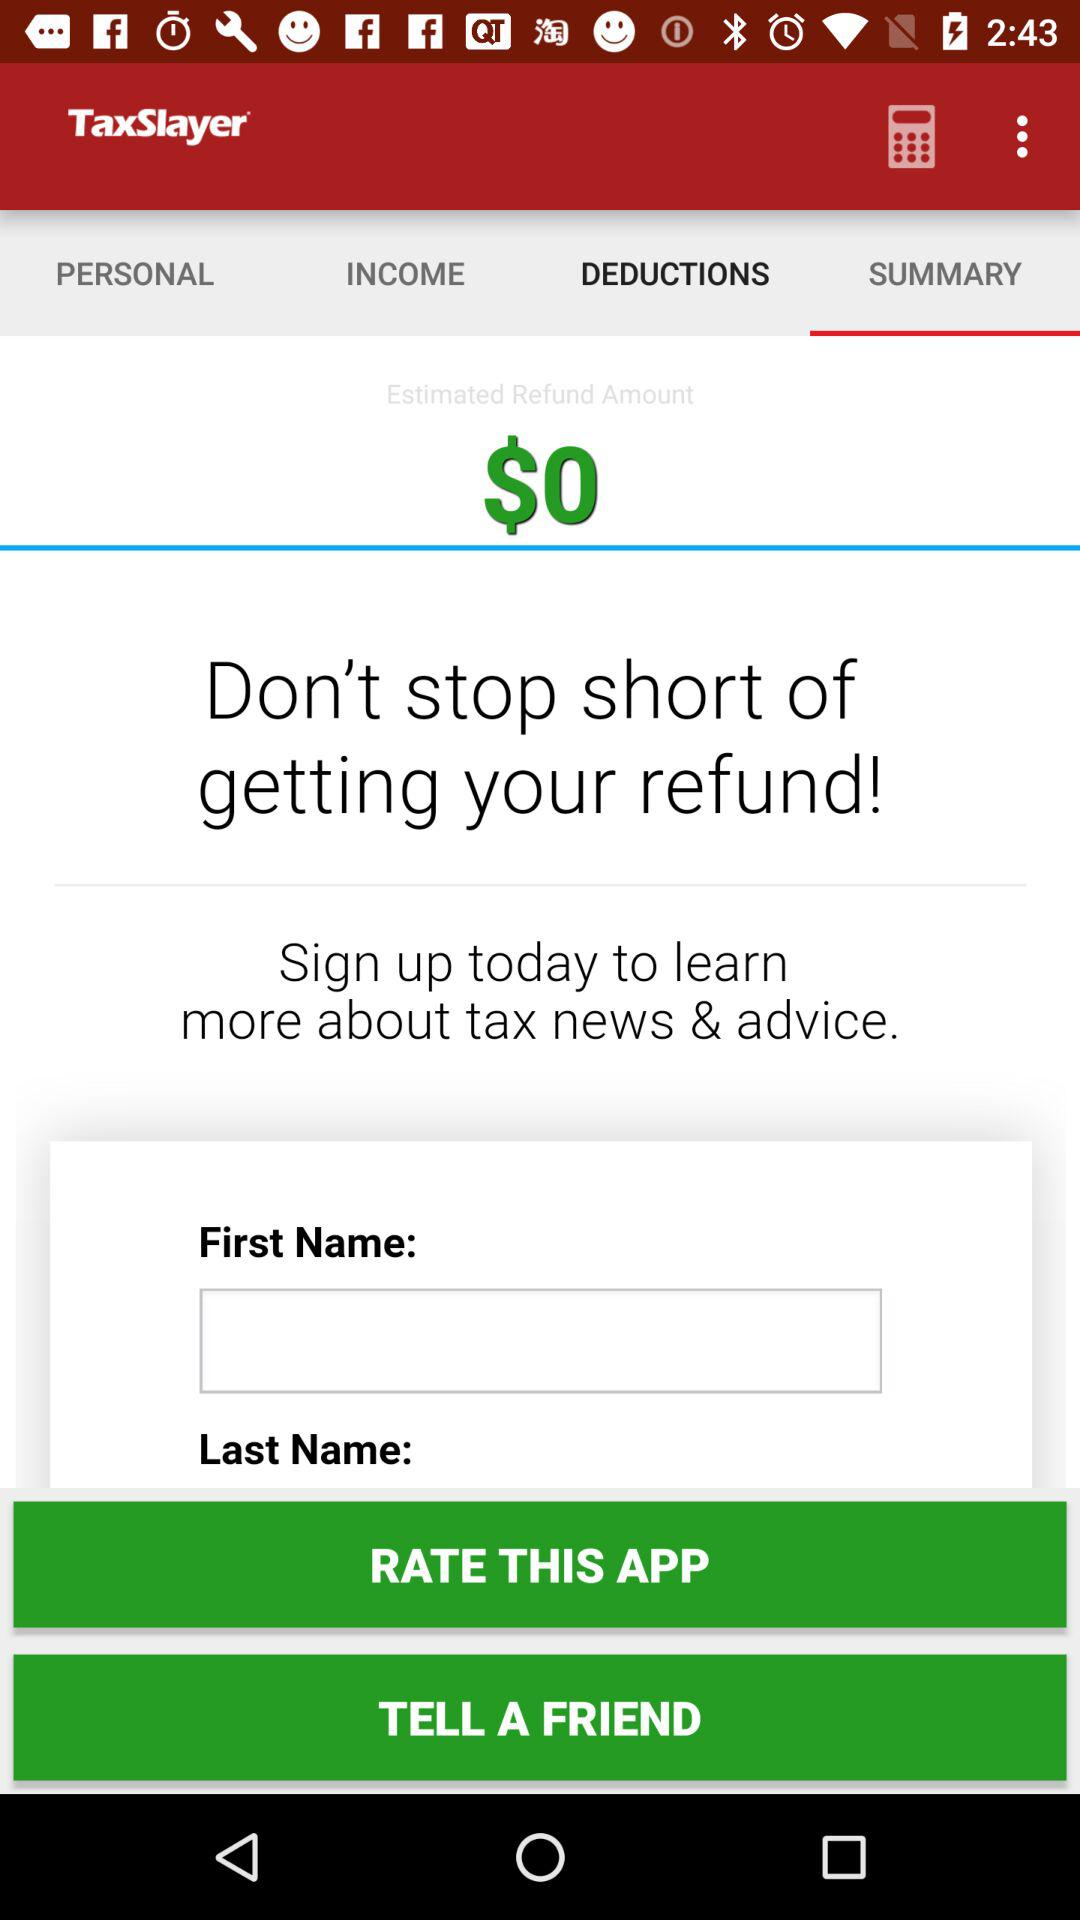What is the estimated refund amount? The estimated refund amount is $0. 